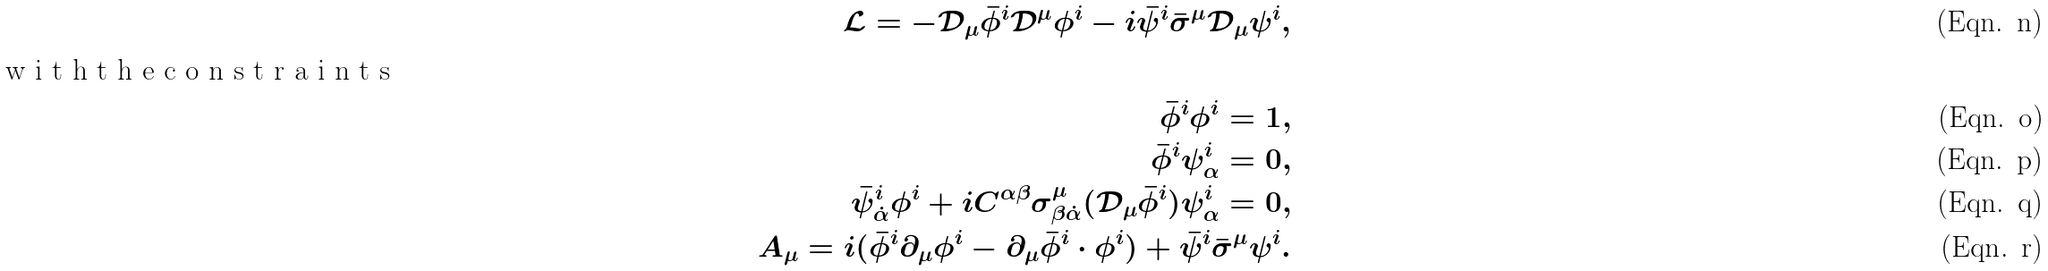Convert formula to latex. <formula><loc_0><loc_0><loc_500><loc_500>\mathcal { L } = - \mathcal { D } _ { \mu } \bar { \phi } ^ { i } \mathcal { D } ^ { \mu } \phi ^ { i } - i \bar { \psi } ^ { i } \bar { \sigma } ^ { \mu } \mathcal { D } _ { \mu } \psi ^ { i } , \\ \intertext { w i t h t h e c o n s t r a i n t s } \bar { \phi } ^ { i } \phi ^ { i } = 1 , \\ \bar { \phi } ^ { i } \psi ^ { i } _ { \alpha } = 0 , \\ \bar { \psi } ^ { i } _ { \dot { \alpha } } \phi ^ { i } + i C ^ { \alpha \beta } \sigma ^ { \mu } _ { \beta \dot { \alpha } } ( \mathcal { D } _ { \mu } \bar { \phi } ^ { i } ) \psi ^ { i } _ { \alpha } = 0 , \\ A _ { \mu } = i ( \bar { \phi } ^ { i } \partial _ { \mu } \phi ^ { i } - \partial _ { \mu } \bar { \phi } ^ { i } \cdot \phi ^ { i } ) + \bar { \psi } ^ { i } \bar { \sigma } ^ { \mu } \psi ^ { i } .</formula> 